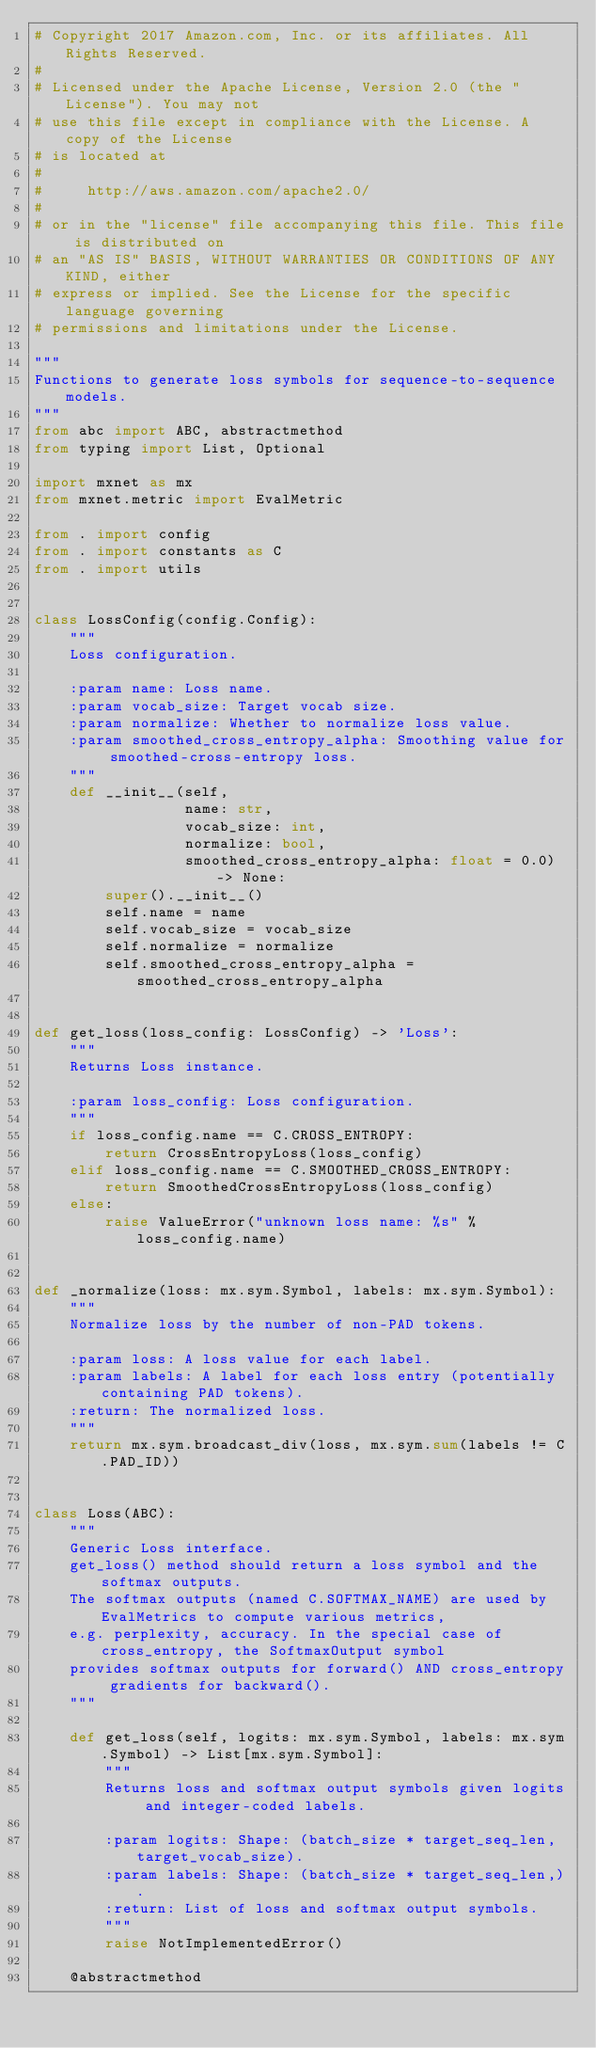<code> <loc_0><loc_0><loc_500><loc_500><_Python_># Copyright 2017 Amazon.com, Inc. or its affiliates. All Rights Reserved.
#
# Licensed under the Apache License, Version 2.0 (the "License"). You may not
# use this file except in compliance with the License. A copy of the License
# is located at
#
#     http://aws.amazon.com/apache2.0/
#
# or in the "license" file accompanying this file. This file is distributed on
# an "AS IS" BASIS, WITHOUT WARRANTIES OR CONDITIONS OF ANY KIND, either
# express or implied. See the License for the specific language governing
# permissions and limitations under the License.

"""
Functions to generate loss symbols for sequence-to-sequence models.
"""
from abc import ABC, abstractmethod
from typing import List, Optional

import mxnet as mx
from mxnet.metric import EvalMetric

from . import config
from . import constants as C
from . import utils


class LossConfig(config.Config):
    """
    Loss configuration.

    :param name: Loss name.
    :param vocab_size: Target vocab size.
    :param normalize: Whether to normalize loss value.
    :param smoothed_cross_entropy_alpha: Smoothing value for smoothed-cross-entropy loss.
    """
    def __init__(self,
                 name: str,
                 vocab_size: int,
                 normalize: bool,
                 smoothed_cross_entropy_alpha: float = 0.0) -> None:
        super().__init__()
        self.name = name
        self.vocab_size = vocab_size
        self.normalize = normalize
        self.smoothed_cross_entropy_alpha = smoothed_cross_entropy_alpha


def get_loss(loss_config: LossConfig) -> 'Loss':
    """
    Returns Loss instance.

    :param loss_config: Loss configuration.
    """
    if loss_config.name == C.CROSS_ENTROPY:
        return CrossEntropyLoss(loss_config)
    elif loss_config.name == C.SMOOTHED_CROSS_ENTROPY:
        return SmoothedCrossEntropyLoss(loss_config)
    else:
        raise ValueError("unknown loss name: %s" % loss_config.name)


def _normalize(loss: mx.sym.Symbol, labels: mx.sym.Symbol):
    """
    Normalize loss by the number of non-PAD tokens.

    :param loss: A loss value for each label.
    :param labels: A label for each loss entry (potentially containing PAD tokens).
    :return: The normalized loss.
    """
    return mx.sym.broadcast_div(loss, mx.sym.sum(labels != C.PAD_ID))


class Loss(ABC):
    """
    Generic Loss interface.
    get_loss() method should return a loss symbol and the softmax outputs.
    The softmax outputs (named C.SOFTMAX_NAME) are used by EvalMetrics to compute various metrics,
    e.g. perplexity, accuracy. In the special case of cross_entropy, the SoftmaxOutput symbol
    provides softmax outputs for forward() AND cross_entropy gradients for backward().
    """

    def get_loss(self, logits: mx.sym.Symbol, labels: mx.sym.Symbol) -> List[mx.sym.Symbol]:
        """
        Returns loss and softmax output symbols given logits and integer-coded labels.

        :param logits: Shape: (batch_size * target_seq_len, target_vocab_size).
        :param labels: Shape: (batch_size * target_seq_len,).
        :return: List of loss and softmax output symbols.
        """
        raise NotImplementedError()

    @abstractmethod</code> 